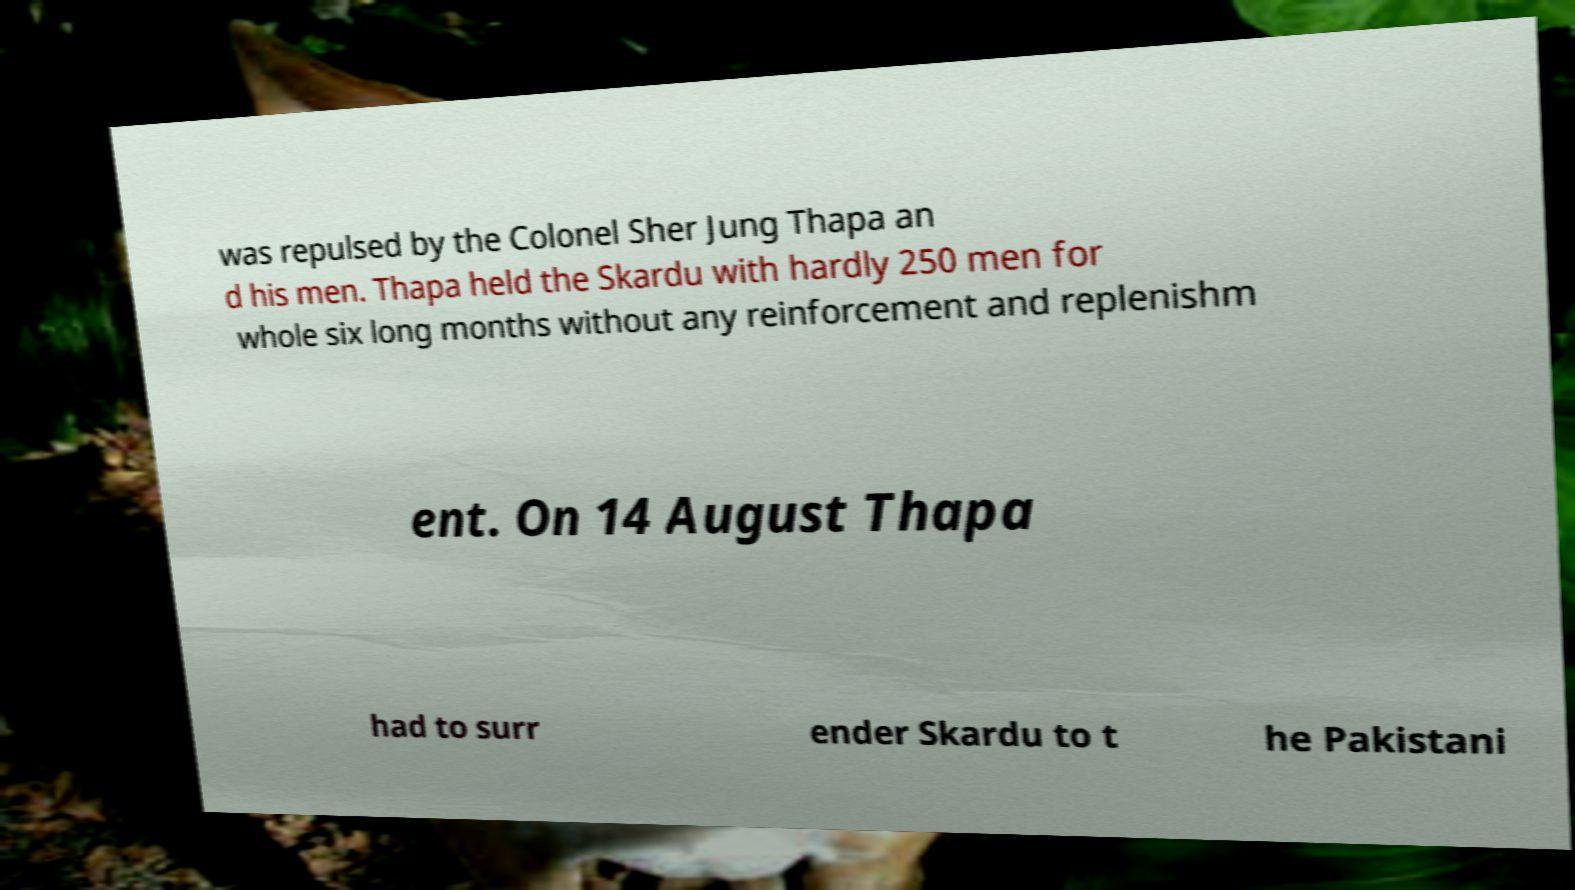Please read and relay the text visible in this image. What does it say? was repulsed by the Colonel Sher Jung Thapa an d his men. Thapa held the Skardu with hardly 250 men for whole six long months without any reinforcement and replenishm ent. On 14 August Thapa had to surr ender Skardu to t he Pakistani 